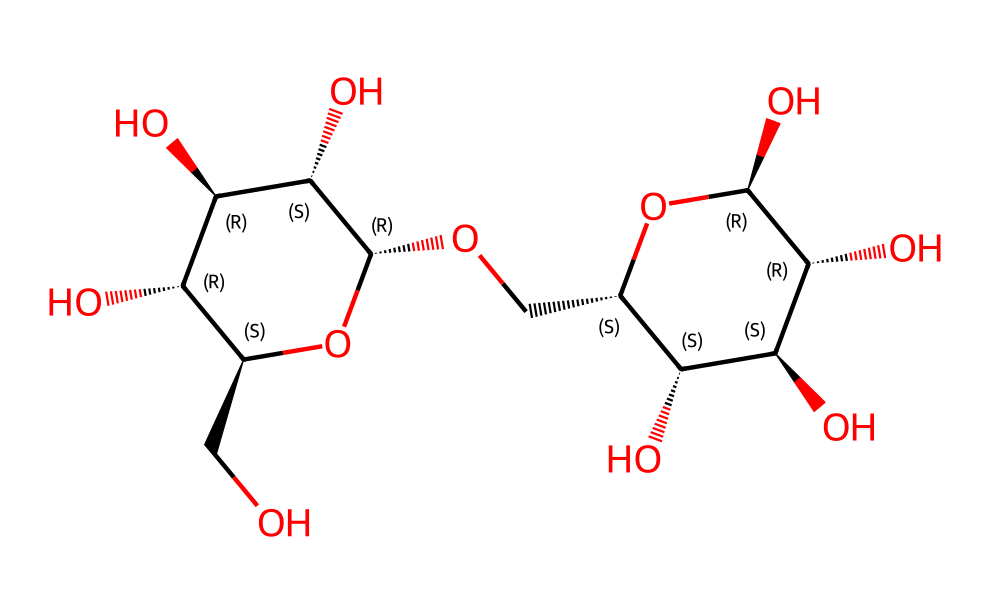how many carbon atoms are in this structure? By examining the SMILES representation, we can identify the number of carbon (C) symbols present, which indicates the carbon atoms in the molecular structure. Count each "C" in the SMILES to find that there are a total of 12 carbon atoms.
Answer: 12 how many hydroxyl groups are present in this chemical? In the SMILES representation, we look for the presence of hydroxyl groups, which are indicated by "O" connected to a carbon atom. By analyzing the structure, we can count that there are 6 hydroxyl groups.
Answer: 6 what type of carbohydrate is represented by this SMILES? The given SMILES corresponds to a polysaccharide due to its complexity and the presence of multiple sugar units linked together. The structure shown is indicative of starch, which is a polysaccharide.
Answer: polysaccharide how many rings are present in this molecular structure? Observing the SMILES representation, we need to identify the cyclical structures within it. The "1" indicates the start and end of cycles; in this case, we find two instances of "1," suggesting there are two ring structures present.
Answer: 2 what is the main functional group present in this carbohydrate? The primary functional group in this carbohydrate is the hydroxyl group (-OH), characterized by the oxygen atom directly bonded to a hydrogen atom. This feature is prominent and representative of alcohols, commonly found in carbohydrates.
Answer: hydroxyl group 